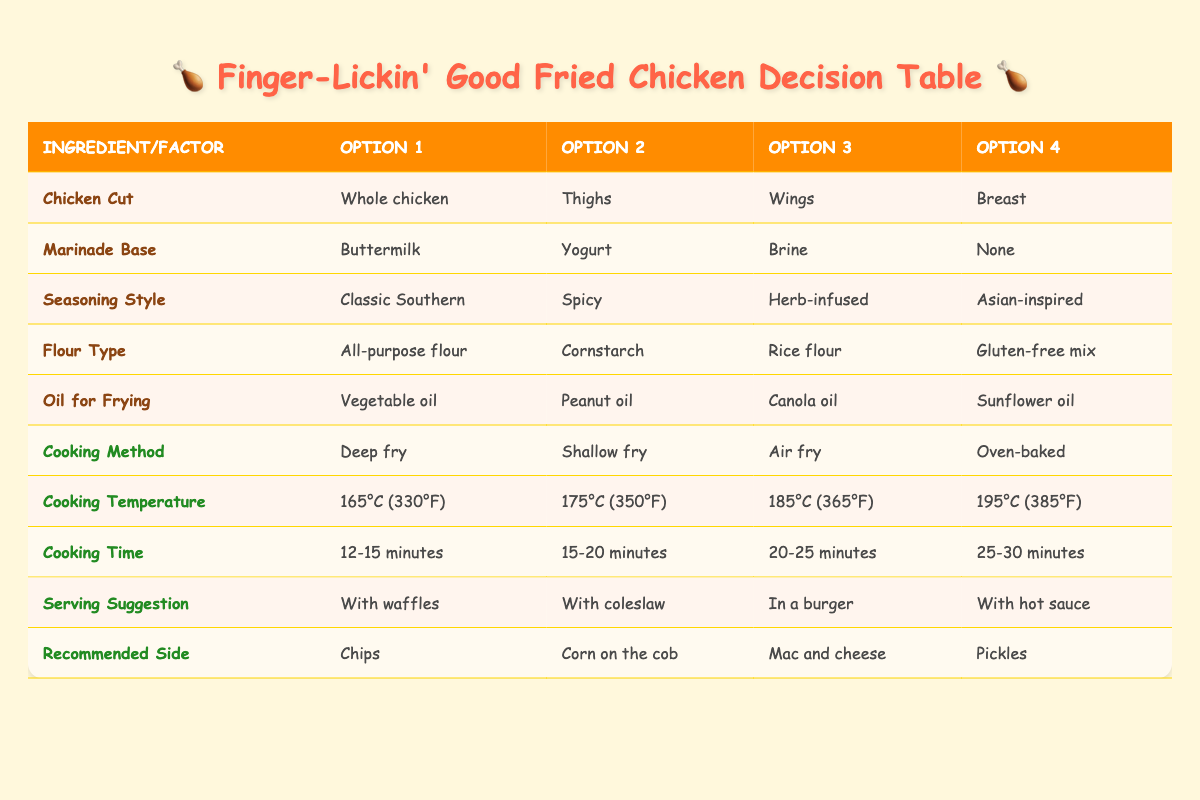What are the available options for the Chicken Cut? The table lists "Whole chicken," "Thighs," "Wings," and "Breast" as the available options for Chicken Cut.
Answer: Whole chicken, Thighs, Wings, Breast Is Buttermilk a possible Marinade Base? The table shows that Buttermilk is listed as one of the options under Marinade Base, indicating that it is indeed a possible choice.
Answer: Yes How many Cooking Methods are listed in the table? There are four options for Cooking Method listed in the table: "Deep fry," "Shallow fry," "Air fry," and "Oven-baked," which sums up to a total of four methods.
Answer: 4 If I choose to use Wings, what could be an accompanying Serving Suggestion? The table does not directly connect specific Chicken Cuts with Serving Suggestions, but it lists "With waffles," "With coleslaw," "In a burger," and "With hot sauce" as general suggestions. Therefore, any of these options could accompany Wings.
Answer: Any of the listed suggestions What is the Cooking Temperature for deep fried chicken and what is the Cooking Time associated with it? The table shows that for deep frying, the Cooking Temperature options are "165°C (330°F)," "175°C (350°F)," "185°C (365°F)," and "195°C (385°F)." The Cooking Time options are "12-15 minutes," "15-20 minutes," "20-25 minutes," and "25-30 minutes." You can choose any combination but the common choice is to deep fry at a higher temperature such as 175°C (350°F) for 15-20 minutes.
Answer: 175°C (350°F), 15-20 minutes If I want to make a gluten-free fried chicken, what should I choose for Flour Type? The table indicates that "Gluten-free mix" is an option listed under Flour Type, which would be suitable for making gluten-free fried chicken.
Answer: Gluten-free mix Is it possible to use rice flour and peanut oil together in a fried chicken recipe? The table shows that both "Rice flour" and "Peanut oil" are listed as options under different categories (Flour Type and Oil for Frying, respectively). This means you can use both together in a fried chicken recipe.
Answer: Yes What are all the combinations of Marinade Base and Seasoning Style that can be used? To find the combinations, take each Marinade Base option: "Buttermilk," "Yogurt," "Brine," "None," and combine each with the Seasoning Style options: "Classic Southern," "Spicy," "Herb-infused," "Asian-inspired." Thus, there are 4 Marinade Bases × 4 Seasoning Styles = 16 combinations in total.
Answer: 16 combinations 